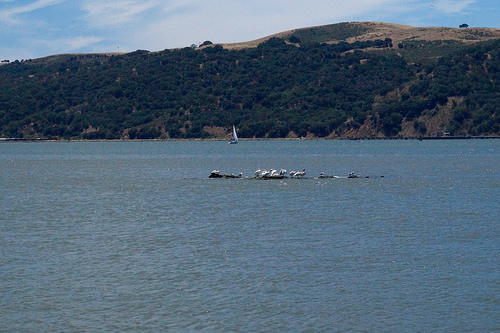<image>
Can you confirm if the birds is on the water? Yes. Looking at the image, I can see the birds is positioned on top of the water, with the water providing support. 